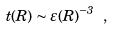<formula> <loc_0><loc_0><loc_500><loc_500>t ( R ) \sim \varepsilon ( R ) ^ { - 3 } \ ,</formula> 